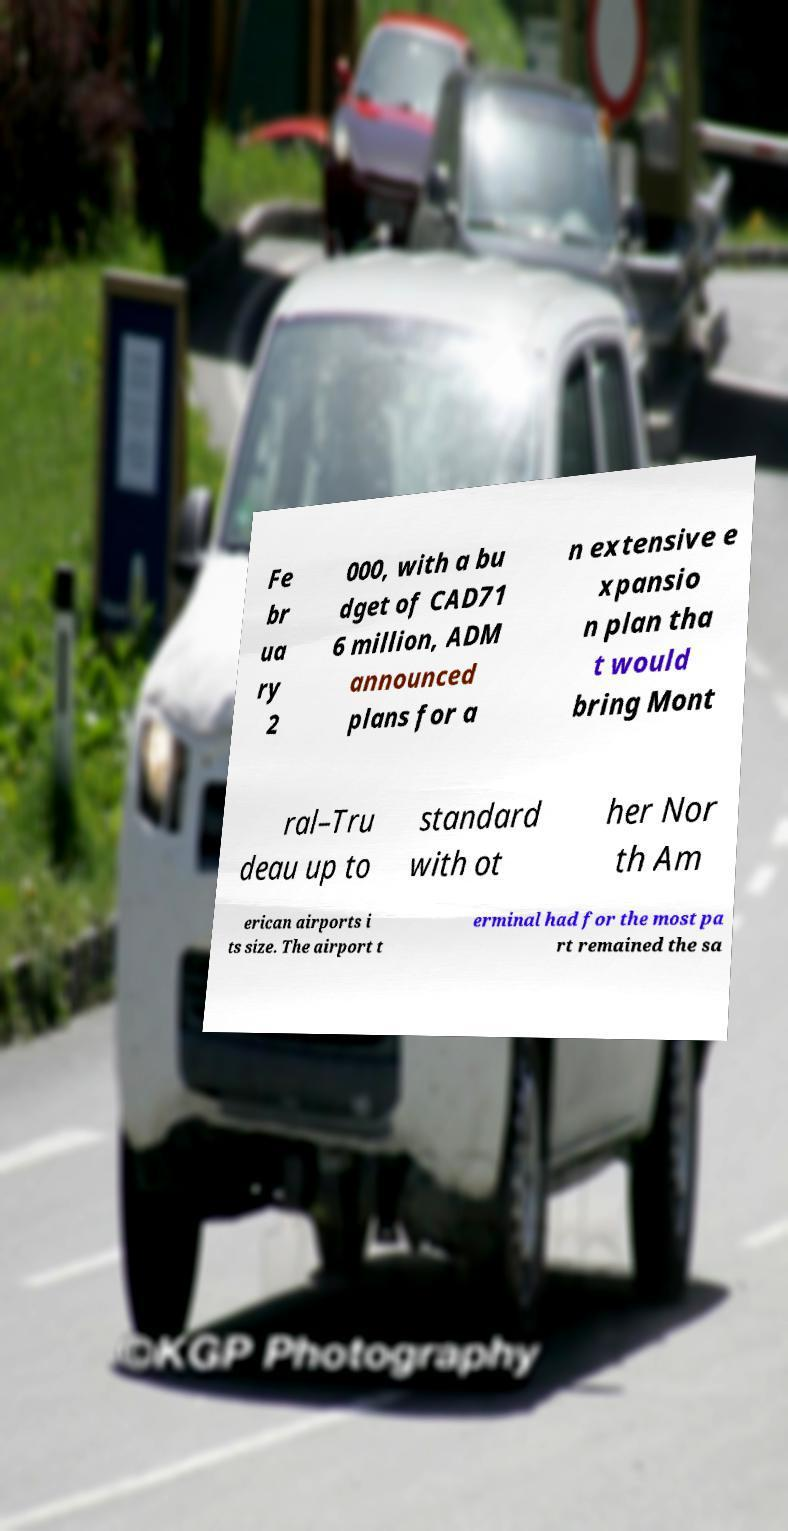I need the written content from this picture converted into text. Can you do that? Fe br ua ry 2 000, with a bu dget of CAD71 6 million, ADM announced plans for a n extensive e xpansio n plan tha t would bring Mont ral–Tru deau up to standard with ot her Nor th Am erican airports i ts size. The airport t erminal had for the most pa rt remained the sa 